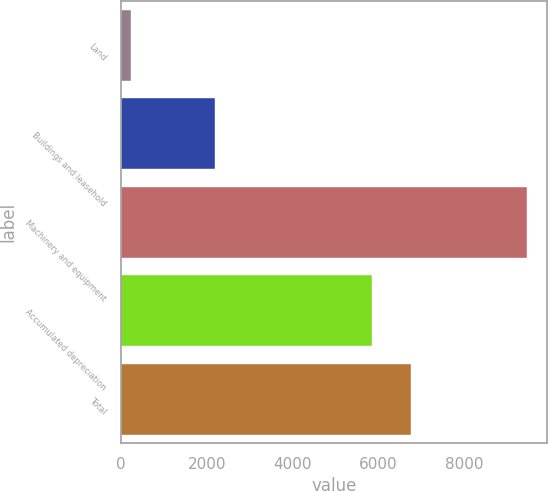Convert chart to OTSL. <chart><loc_0><loc_0><loc_500><loc_500><bar_chart><fcel>Land<fcel>Buildings and leasehold<fcel>Machinery and equipment<fcel>Accumulated depreciation<fcel>Total<nl><fcel>241<fcel>2196<fcel>9464<fcel>5847<fcel>6769.3<nl></chart> 